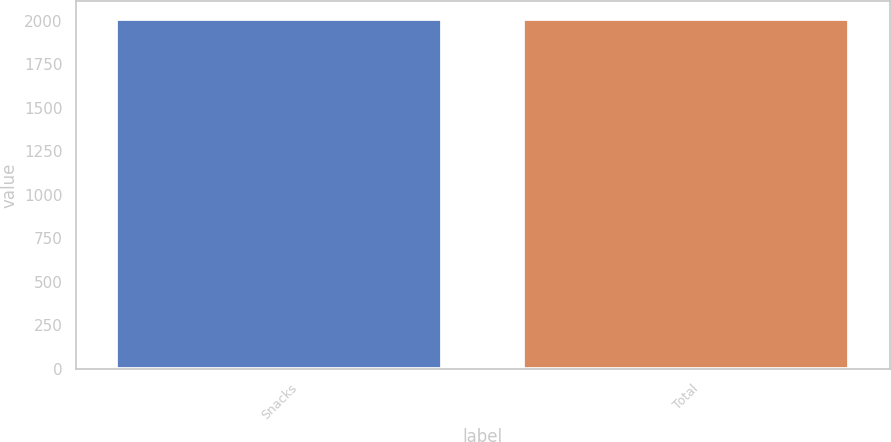Convert chart. <chart><loc_0><loc_0><loc_500><loc_500><bar_chart><fcel>Snacks<fcel>Total<nl><fcel>2012<fcel>2012.1<nl></chart> 